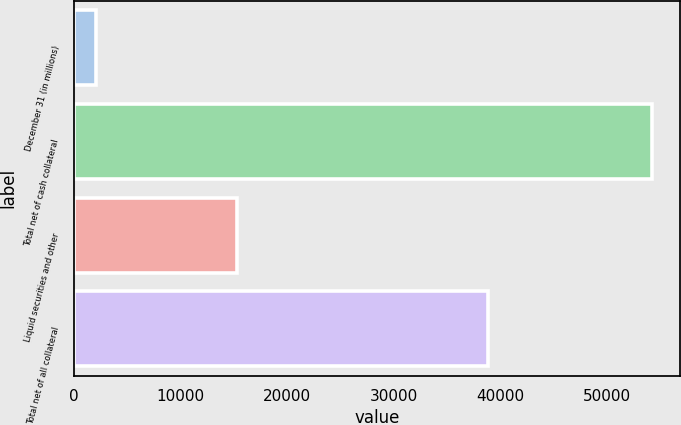Convert chart. <chart><loc_0><loc_0><loc_500><loc_500><bar_chart><fcel>December 31 (in millions)<fcel>Total net of cash collateral<fcel>Liquid securities and other<fcel>Total net of all collateral<nl><fcel>2018<fcel>54213<fcel>15322<fcel>38891<nl></chart> 